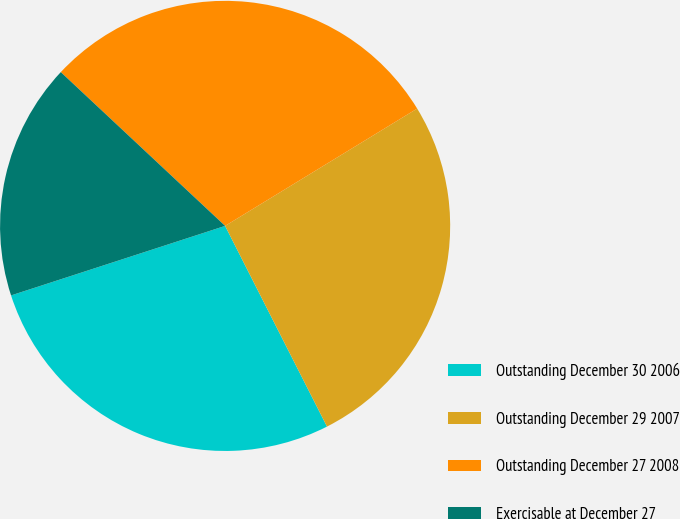<chart> <loc_0><loc_0><loc_500><loc_500><pie_chart><fcel>Outstanding December 30 2006<fcel>Outstanding December 29 2007<fcel>Outstanding December 27 2008<fcel>Exercisable at December 27<nl><fcel>27.48%<fcel>26.25%<fcel>29.3%<fcel>16.97%<nl></chart> 